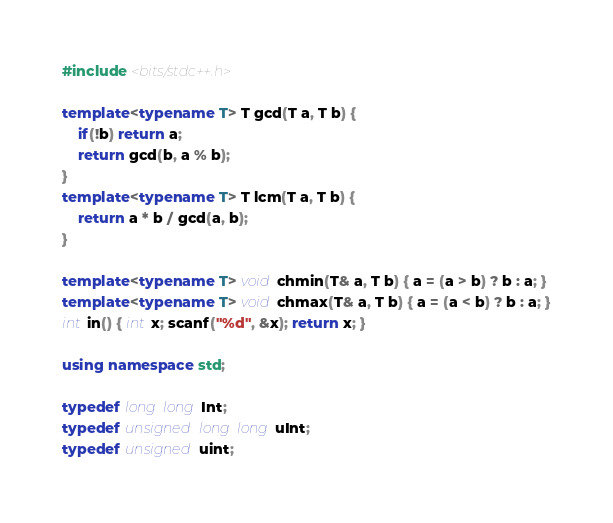Convert code to text. <code><loc_0><loc_0><loc_500><loc_500><_C++_>#include <bits/stdc++.h>

template<typename T> T gcd(T a, T b) {
    if(!b) return a;
    return gcd(b, a % b);
}
template<typename T> T lcm(T a, T b) {
    return a * b / gcd(a, b);
}

template<typename T> void chmin(T& a, T b) { a = (a > b) ? b : a; }
template<typename T> void chmax(T& a, T b) { a = (a < b) ? b : a; }
int in() { int x; scanf("%d", &x); return x; }

using namespace std;

typedef long long Int;
typedef unsigned long long uInt;
typedef unsigned uint;
</code> 